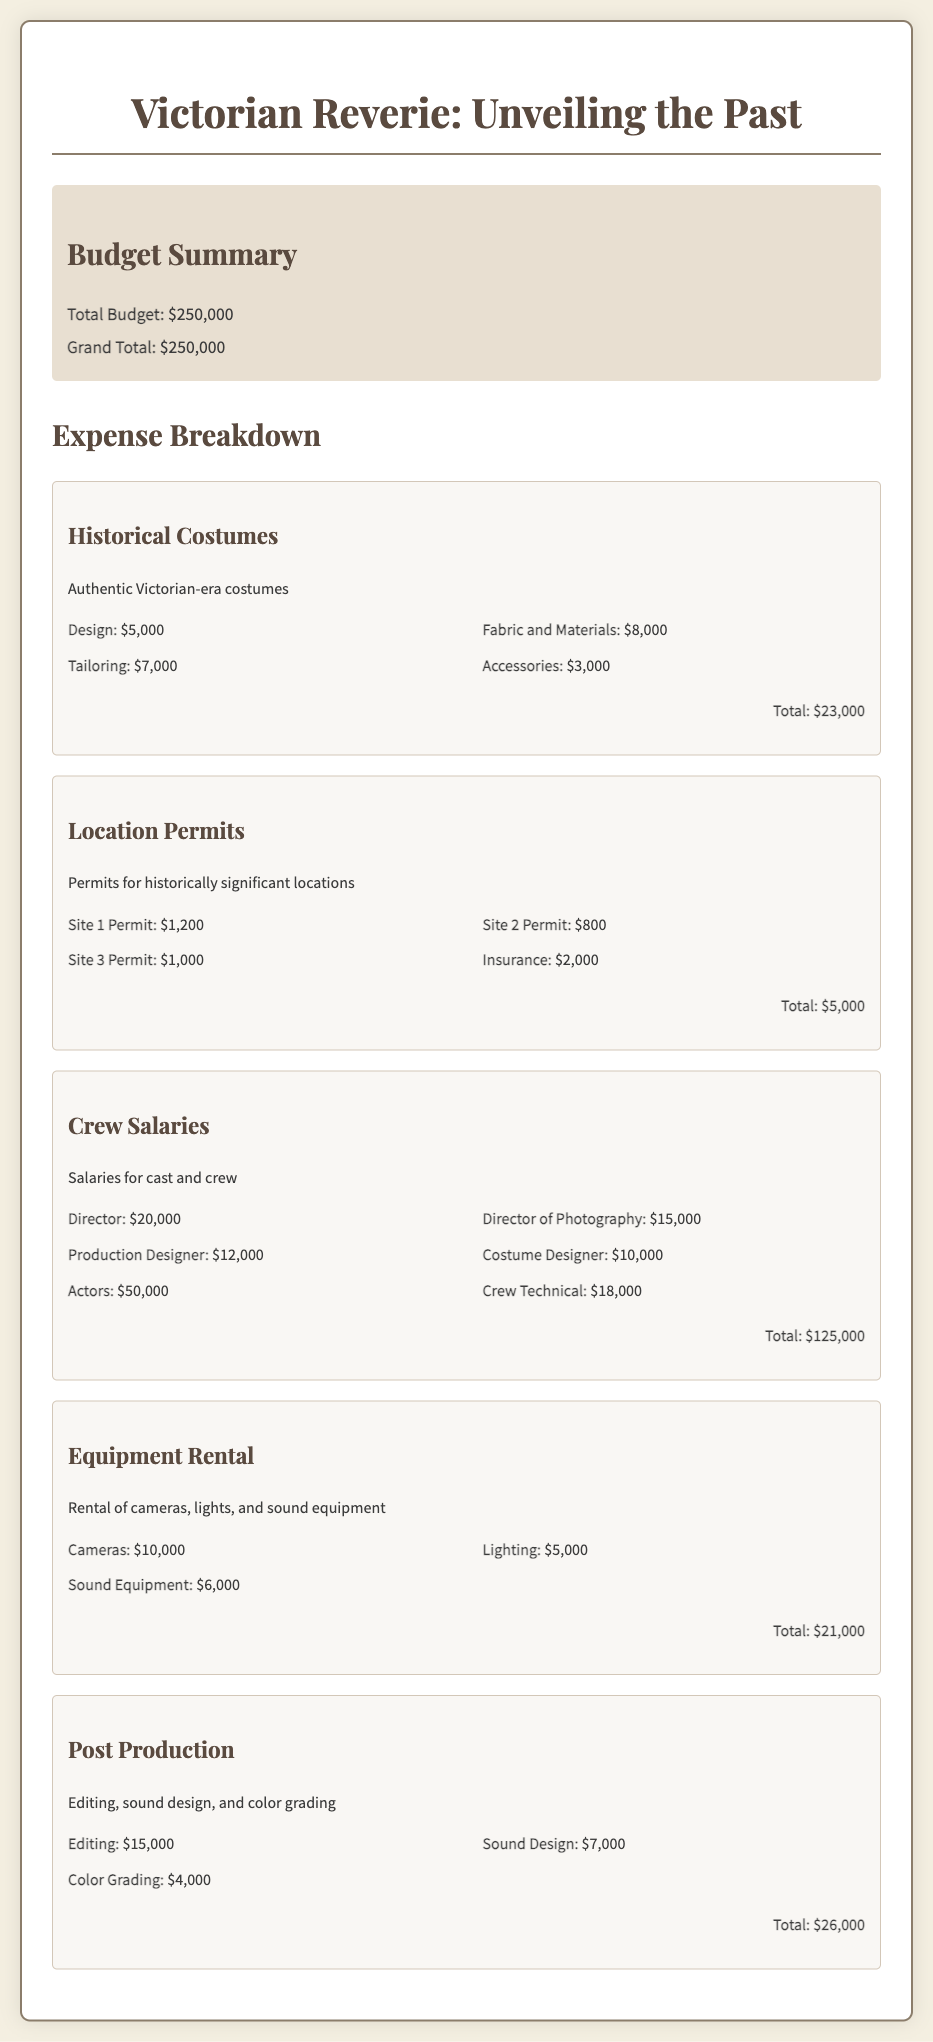What is the total budget? The total budget is clearly stated in the document as $250,000.
Answer: $250,000 How much is allocated for historical costumes? The document provides a breakdown of historical costumes, totaling $23,000.
Answer: $23,000 What is the cost for the Director of Photography? The specific expense for the Director of Photography is listed as $15,000.
Answer: $15,000 How much does insurance for location permits cost? The insurance cost for location permits is mentioned as $2,000.
Answer: $2,000 What is the total for crew salaries? The crew salaries section totals $125,000, which combines various salaries listed.
Answer: $125,000 What is the expense for sound equipment? The document specifies that the cost for sound equipment is $6,000.
Answer: $6,000 What category has the highest expense? The crew salaries category has the highest total expense at $125,000.
Answer: Crew Salaries If you add the total for equipment rental and post production, what will that amount be? Adding the total for equipment rental ($21,000) and post production ($26,000) results in $47,000.
Answer: $47,000 What percentage of the total budget is spent on location permits? The location permits total $5,000, which is 2% of the total budget of $250,000.
Answer: 2% 